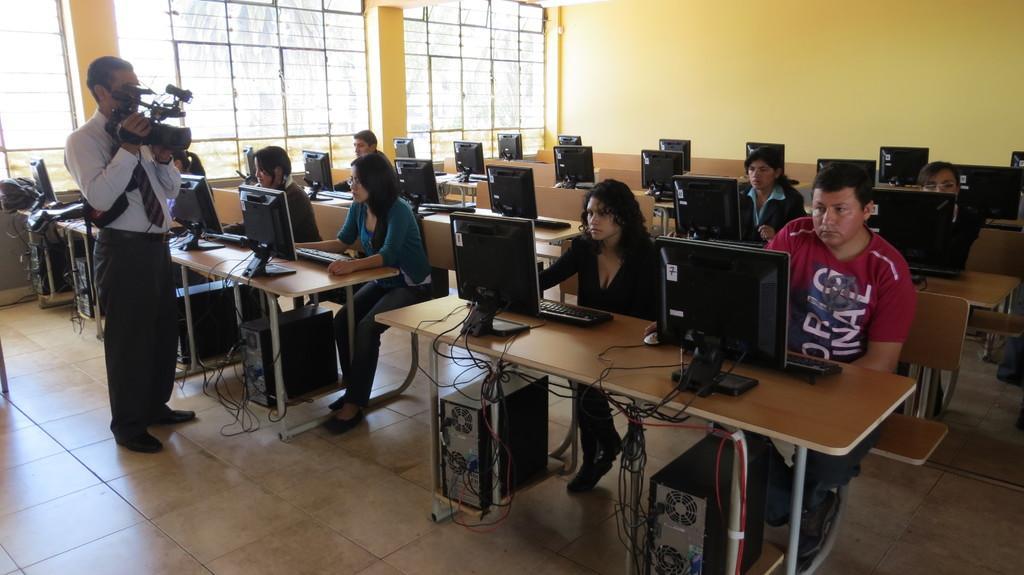Please provide a concise description of this image. This is the picture of a classroom the man holding camera and recording the person what they are doing they are bunch of people in the classroom this is the man in red t shirt behind beside the man there is a women who is wearing black dress this is a yellow wall and they are working in the systems with some work this is glass window behind the glass window there is a tree this is a table this is a monitor this is a keyboard this is a tile floor 